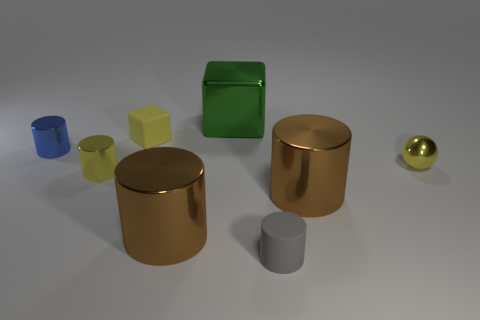Subtract all tiny shiny cylinders. How many cylinders are left? 3 Subtract all purple balls. How many brown cylinders are left? 2 Subtract 3 cylinders. How many cylinders are left? 2 Add 1 large purple matte objects. How many objects exist? 9 Subtract all gray cylinders. How many cylinders are left? 4 Add 1 green metal things. How many green metal things are left? 2 Add 4 green metallic cubes. How many green metallic cubes exist? 5 Subtract 1 brown cylinders. How many objects are left? 7 Subtract all blocks. How many objects are left? 6 Subtract all gray cylinders. Subtract all blue spheres. How many cylinders are left? 4 